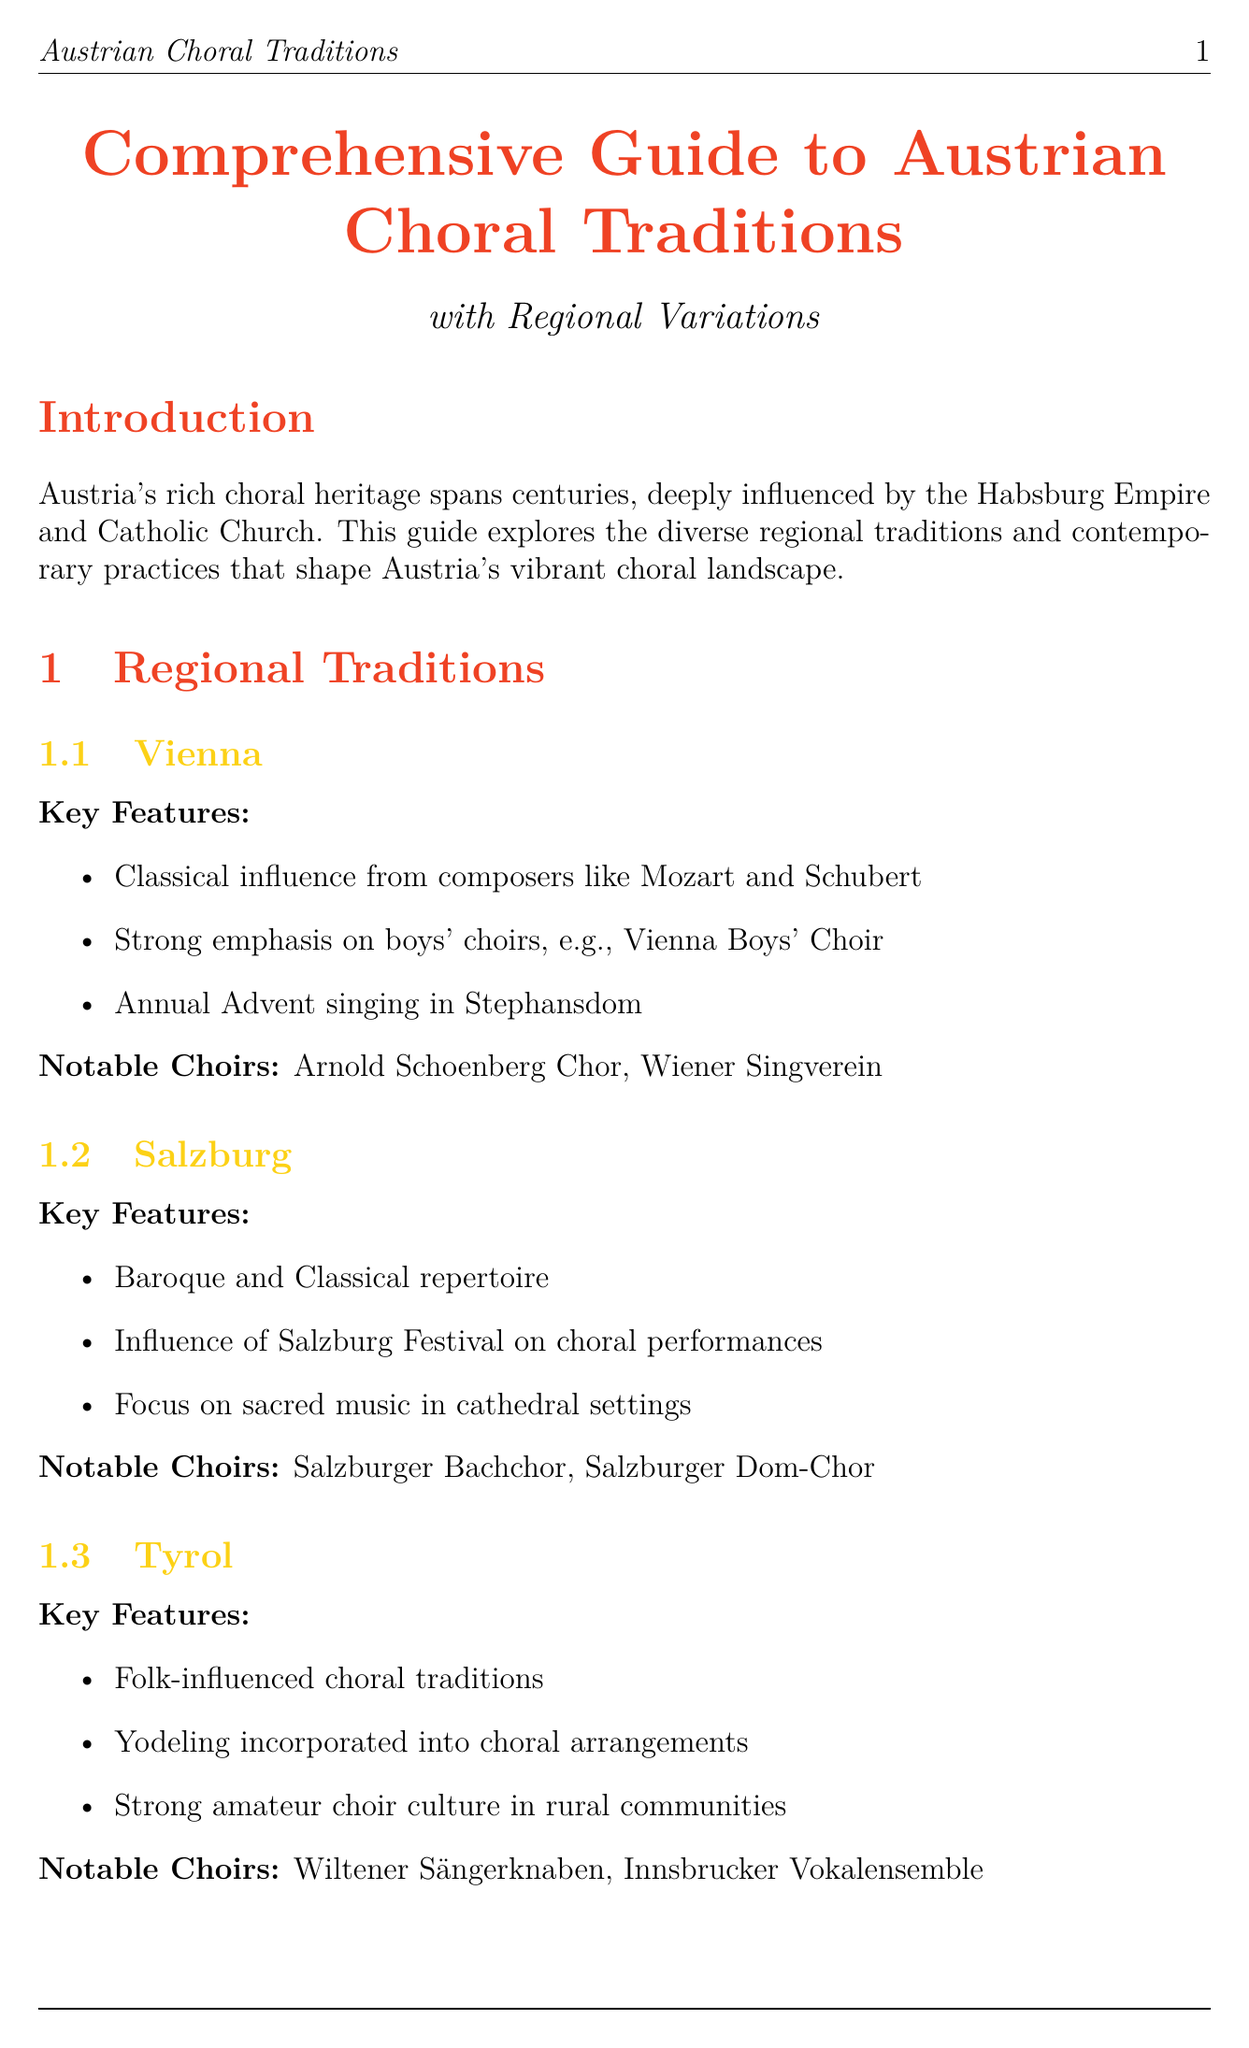What is the main influence on choral music in Austria? The main influence on choral music in Austria is from the Habsburg Empire and Catholic Church.
Answer: Habsburg Empire and Catholic Church How many regions are covered in the guide? The guide covers four regions: Vienna, Salzburg, Tyrol, and Styria.
Answer: Four Which choir is notably associated with Vienna? The notable choirs associated with Vienna include Arnold Schoenberg Chor and Wiener Singverein.
Answer: Arnold Schoenberg Chor What festival takes place annually in Salzburg? The Salzburg Choral Festival is an annual summer festival coinciding with the Salzburg Festival.
Answer: Salzburg Choral Festival What is the Wiener Klangstil? Wiener Klangstil is characterized by a warm tone and precise diction in choral sound.
Answer: Warm tone and precise diction Which institution offers a program in Choral Conducting in Vienna? The University of Music and Performing Arts Vienna offers a program in Choral Conducting.
Answer: University of Music and Performing Arts Vienna What contemporary trend is mentioned regarding Austrian choral music? A contemporary trend is the fusion of traditional Austrian folk music with choral arrangements.
Answer: Fusion of traditional Austrian folk music What type of music is emphasized in Tyrol choral traditions? Tyrol choral traditions emphasize folk-influenced choral traditions.
Answer: Folk-influenced choral traditions Who is a notable conductor affiliated with the Salzburg Bachchor? Philipp von Steinaecker is a notable conductor affiliated with the Salzburg Bachchor.
Answer: Philipp von Steinaecker 